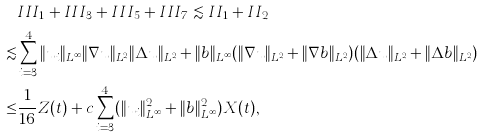<formula> <loc_0><loc_0><loc_500><loc_500>& I I I _ { 1 } + I I I _ { 3 } + I I I _ { 5 } + I I I _ { 7 } \lesssim I I _ { 1 } + I I _ { 2 } \\ \lesssim & \sum _ { i = 3 } ^ { 4 } \| u _ { i } \| _ { L ^ { \infty } } \| \nabla u \| _ { L ^ { 2 } } \| \Delta u \| _ { L ^ { 2 } } + \| b \| _ { L ^ { \infty } } ( \| \nabla u \| _ { L ^ { 2 } } + \| \nabla b \| _ { L ^ { 2 } } ) ( \| \Delta u \| _ { L ^ { 2 } } + \| \Delta b \| _ { L ^ { 2 } } ) \\ \leq & \frac { 1 } { 1 6 } Z ( t ) + c \sum _ { i = 3 } ^ { 4 } ( \| u _ { i } \| _ { L ^ { \infty } } ^ { 2 } + \| b \| _ { L ^ { \infty } } ^ { 2 } ) X ( t ) ,</formula> 